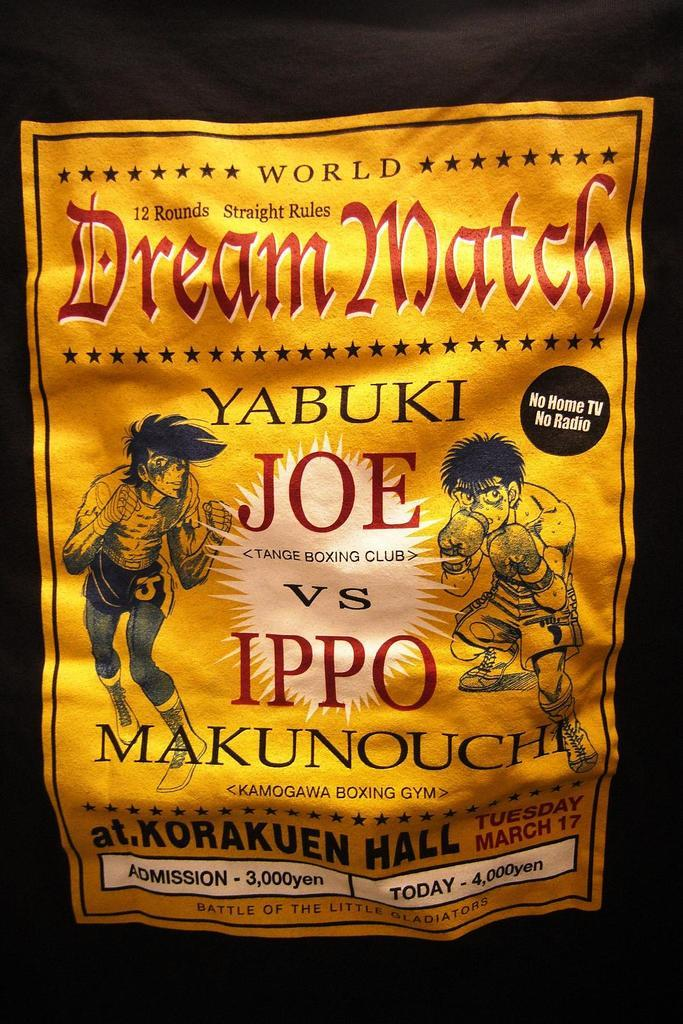Provide a one-sentence caption for the provided image. A World Dream Match event is advertised for today.. 